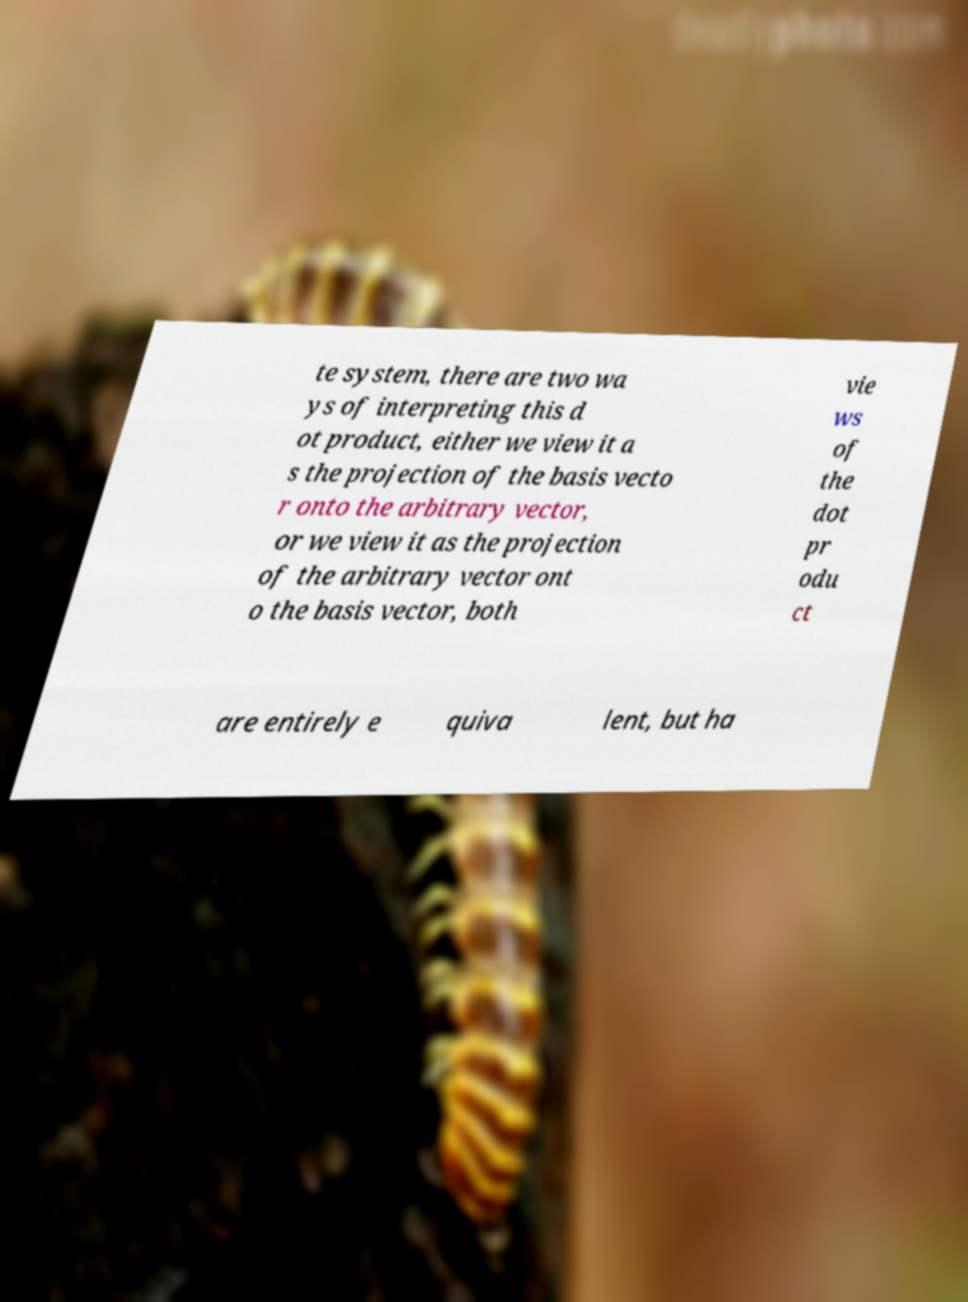Can you read and provide the text displayed in the image?This photo seems to have some interesting text. Can you extract and type it out for me? te system, there are two wa ys of interpreting this d ot product, either we view it a s the projection of the basis vecto r onto the arbitrary vector, or we view it as the projection of the arbitrary vector ont o the basis vector, both vie ws of the dot pr odu ct are entirely e quiva lent, but ha 